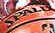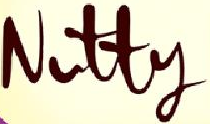Identify the words shown in these images in order, separated by a semicolon. #####; Nutty 